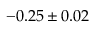<formula> <loc_0><loc_0><loc_500><loc_500>- 0 . 2 5 \pm 0 . 0 2</formula> 